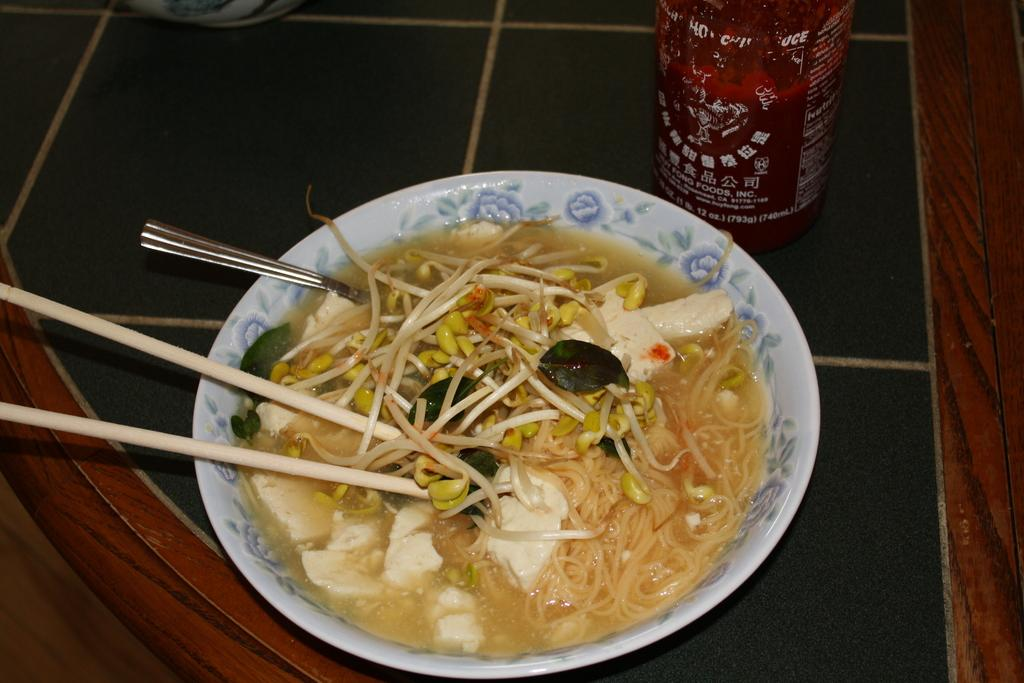What is present on the plate in the image? There is food on the plate in the image. What utensils are visible in the image? There is a spoon and chopsticks in the image. What type of produce is being treated on the slope in the image? There is no produce, treatment, or slope present in the image. 